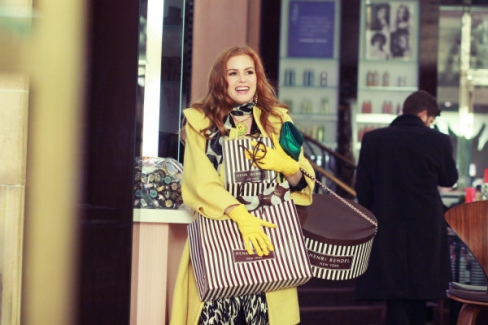What does the setting of the image suggest about the location? The setting of the image, with its chic storefront featuring a striped awning and an elegant glass display filled with scarves, suggests a cosmopolitan area likely within a city known for its fashion or shopping districts. The blurred background showing other pedestrians and architectural details indicates a bustling, lively urban environment, perhaps in a well-traveled part of a city. 